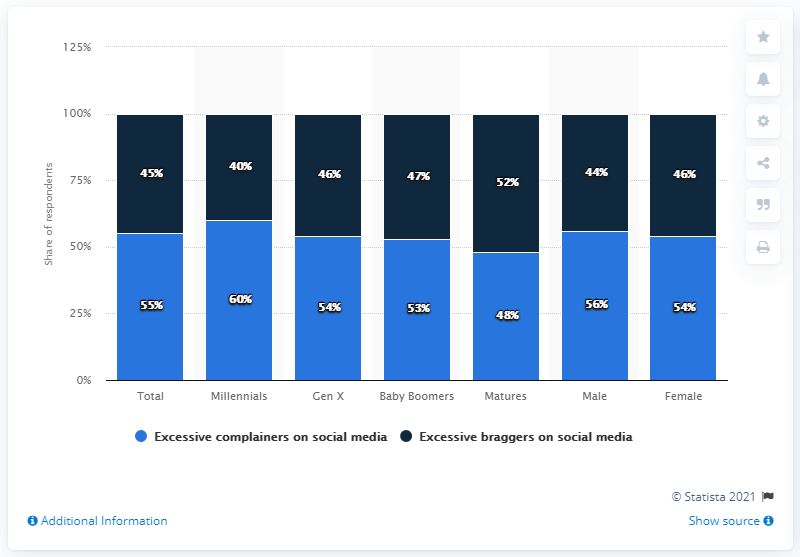Draw attention to some important aspects in this diagram. The average of the blue bar in male and female is 55. Out of the three charts, the blue chart with the highest percentage is 60%. 